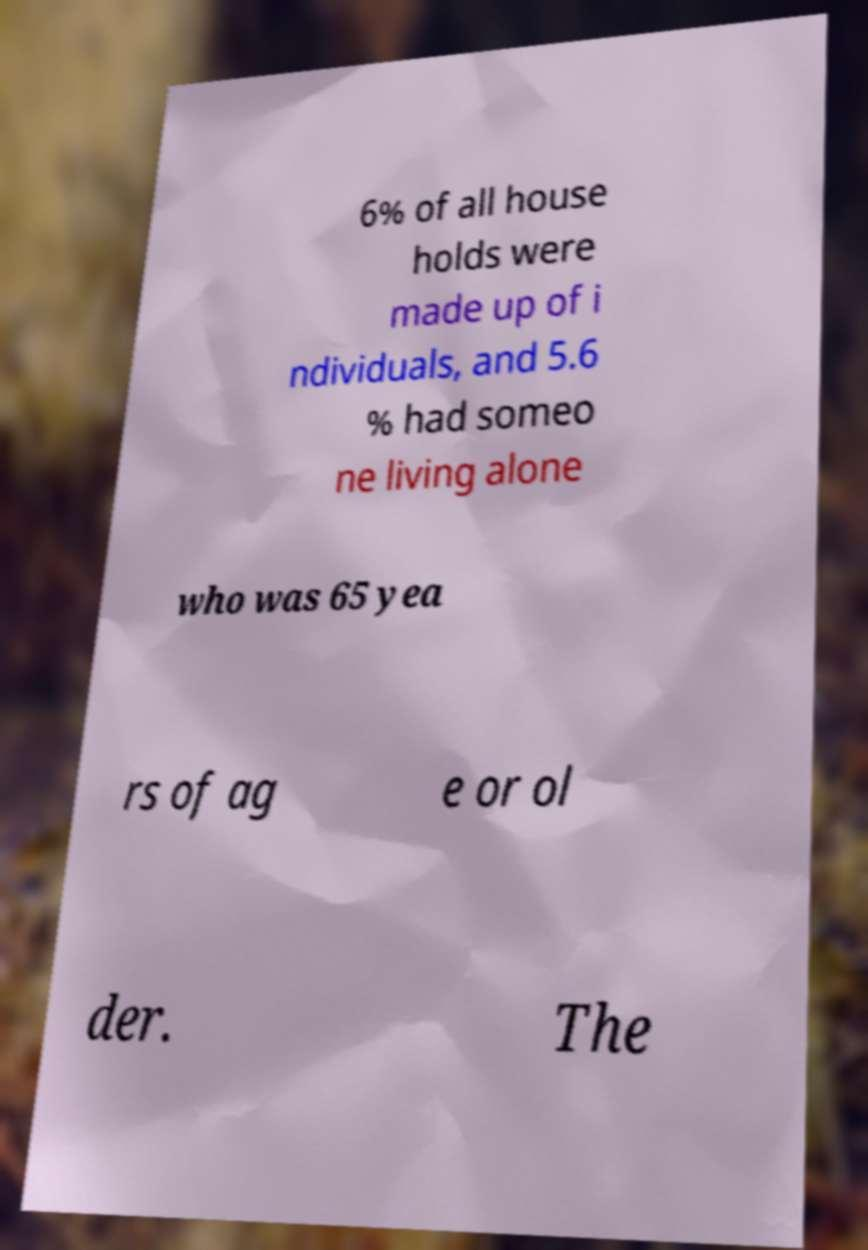For documentation purposes, I need the text within this image transcribed. Could you provide that? 6% of all house holds were made up of i ndividuals, and 5.6 % had someo ne living alone who was 65 yea rs of ag e or ol der. The 